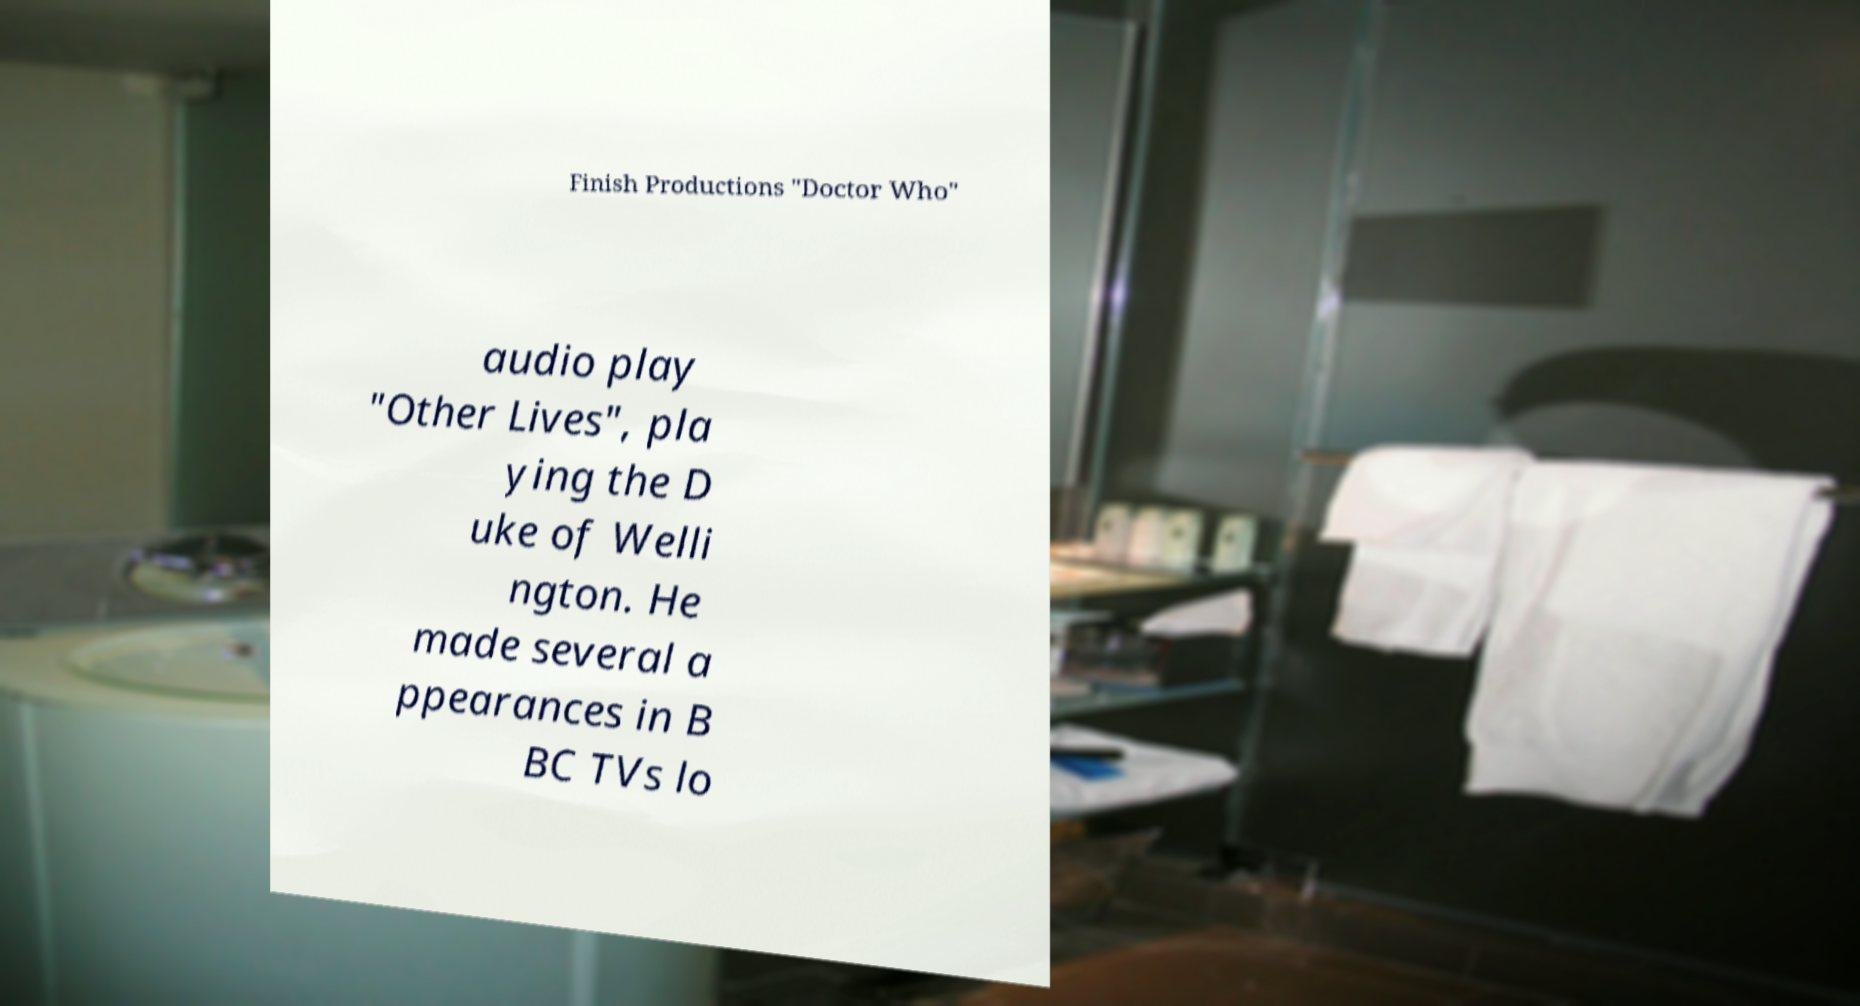There's text embedded in this image that I need extracted. Can you transcribe it verbatim? Finish Productions "Doctor Who" audio play "Other Lives", pla ying the D uke of Welli ngton. He made several a ppearances in B BC TVs lo 